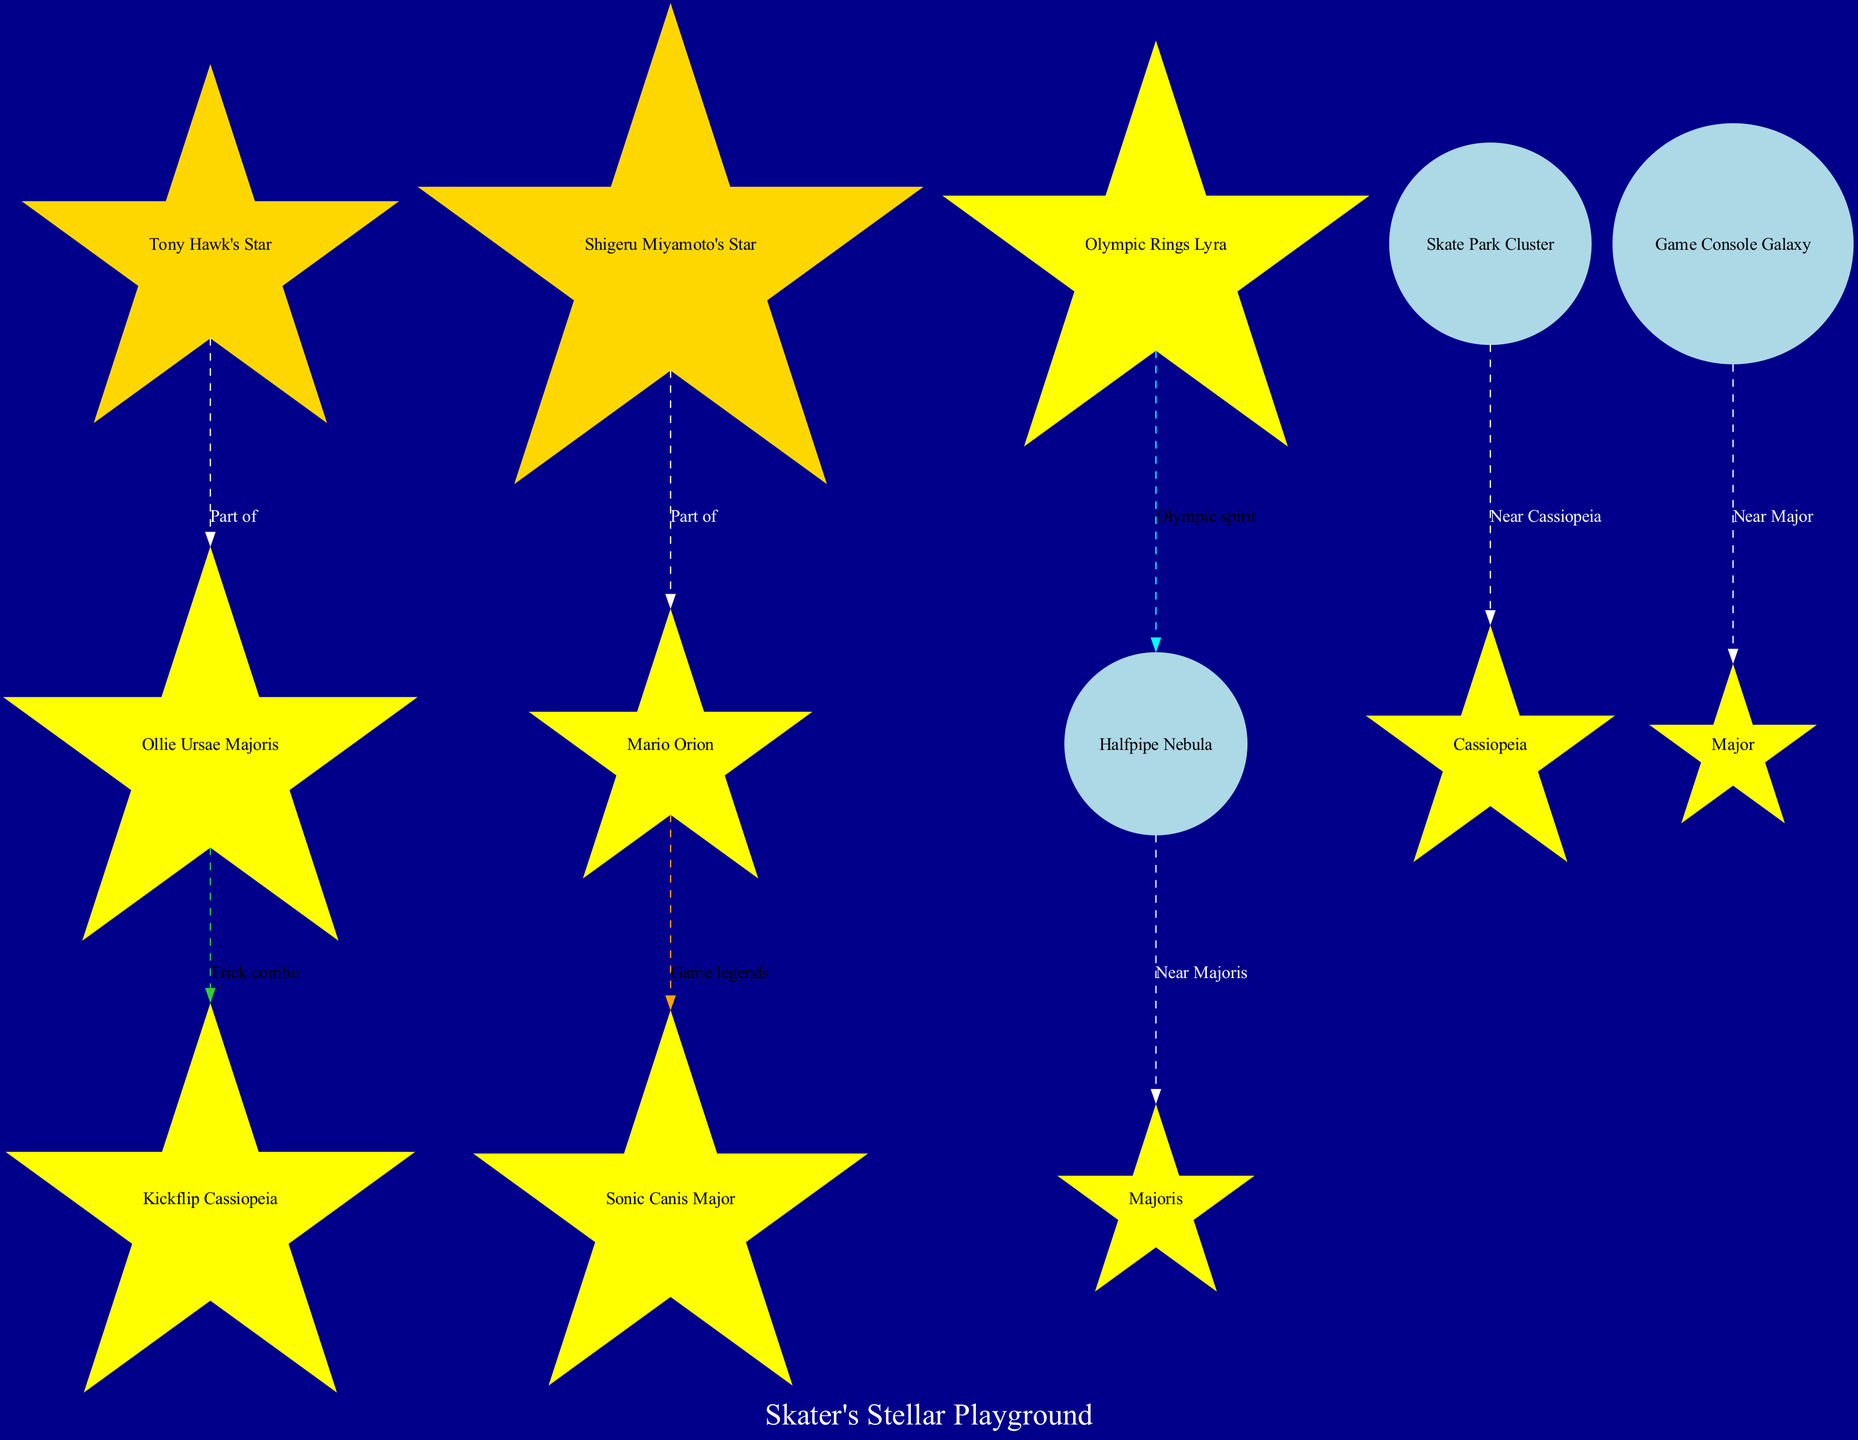What is the title of the diagram? The title of the diagram is specified at the top of the structure, formatted as "Skater's Stellar Playground."
Answer: Skater's Stellar Playground How many constellations are shown in the diagram? The data contains five distinct constellations listed under the "constellations" section: Ollie Ursae Majoris, Kickflip Cassiopeia, Mario Orion, Sonic Canis Major, and Olympic Rings Lyra.
Answer: 5 Which constellation resembles a skateboarder performing an ollie? The specific description for the constellation highlights that "Ollie Ursae Majoris" resembles a skateboarder performing this trick, making it identifiable in the context.
Answer: Ollie Ursae Majoris What celestial object is located near Ollie Ursae Majoris? According to the data, the "Halfpipe Nebula" is mentioned as being located near Ollie Ursae Majoris, directly connecting it to that constellation.
Answer: Halfpipe Nebula Which notable star is part of Mario Orion? The notable star listed that is part of Mario Orion is "Shigeru Miyamoto's Star," which is directly connected to the constellation in the diagram.
Answer: Shigeru Miyamoto's Star What color represents the celestial objects in the diagram? The color assigned to celestial objects in the diagram is specified as "lightblue," providing a visual cue for their differentiation from the constellations.
Answer: Lightblue How do Ollie Ursae Majoris and Kickflip Cassiopeia relate to each other? The two constellations are connected by an edge labeled "Trick combo," indicating a playful connection that reflects a theme of skateboard tricks between them.
Answer: Trick combo What does Olympic Rings Lyra resemble? The description provided indicates that Olympic Rings Lyra resembles five stars arranged like the Olympic rings, specifically tying it to that iconic symbol.
Answer: Olympic rings Which galaxy is situated between Mario Orion and Sonic Canis Major? The data clearly identifies the "Game Console Galaxy" as being the celestial object positioned between these two constellations in the diagram.
Answer: Game Console Galaxy 